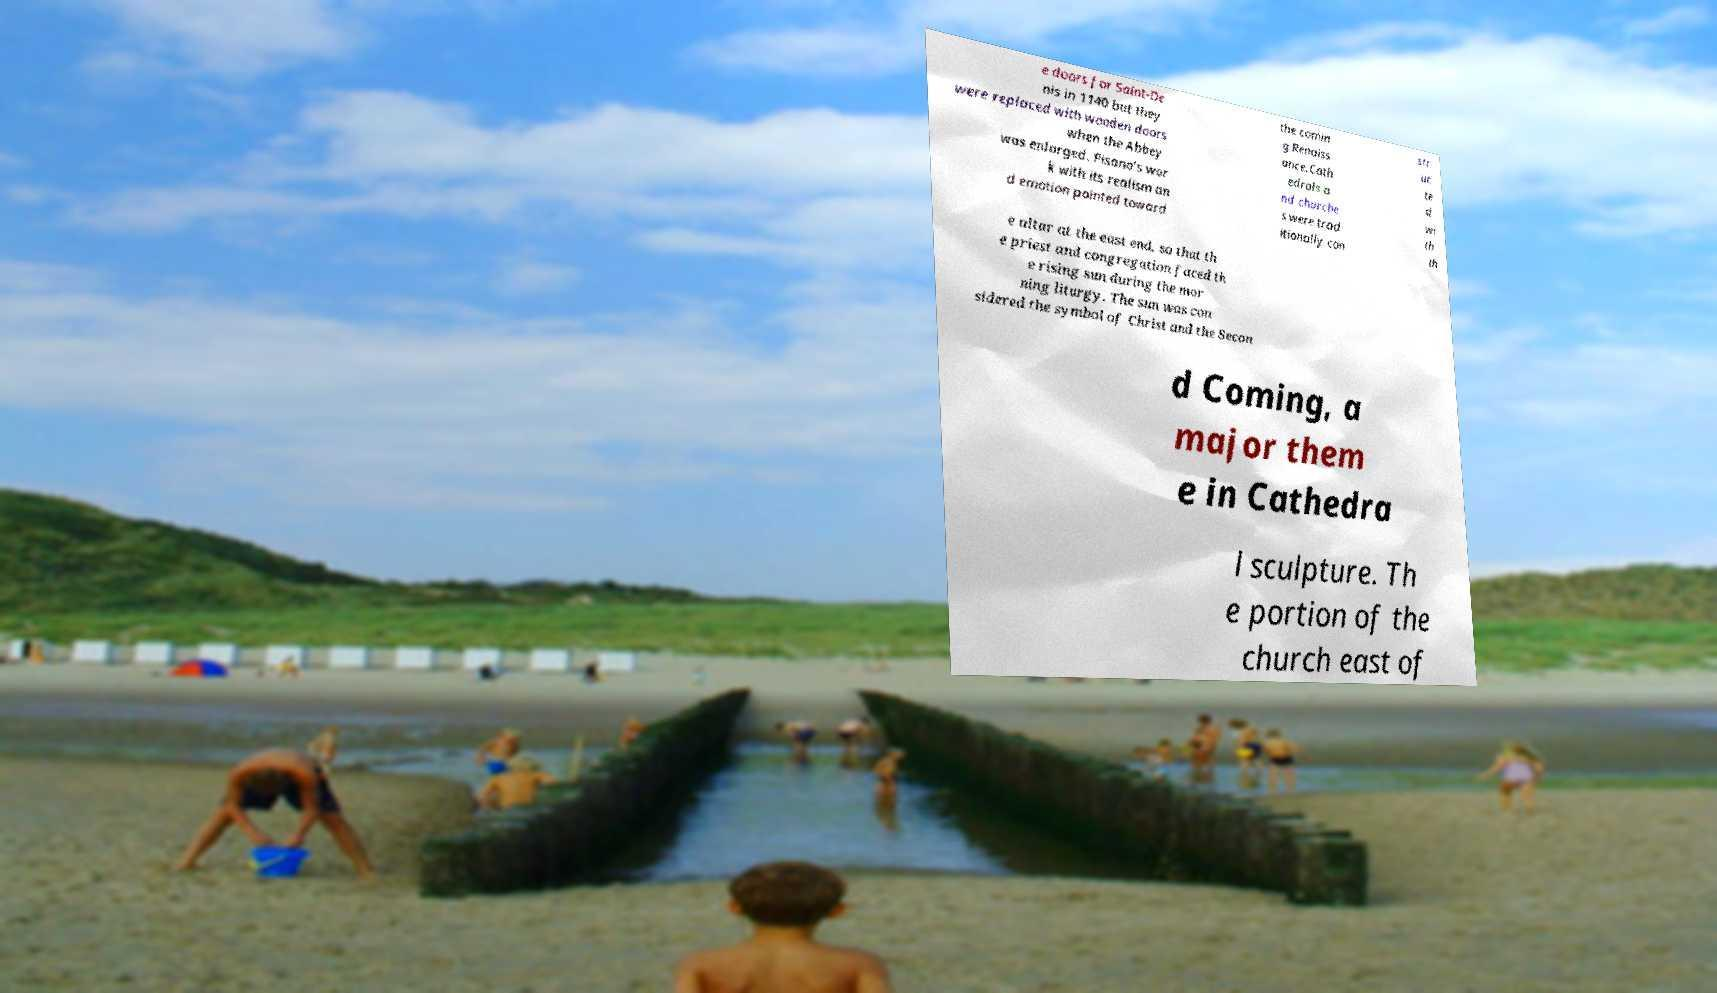There's text embedded in this image that I need extracted. Can you transcribe it verbatim? e doors for Saint-De nis in 1140 but they were replaced with wooden doors when the Abbey was enlarged. Pisano's wor k with its realism an d emotion pointed toward the comin g Renaiss ance.Cath edrals a nd churche s were trad itionally con str uc te d wi th th e altar at the east end, so that th e priest and congregation faced th e rising sun during the mor ning liturgy. The sun was con sidered the symbol of Christ and the Secon d Coming, a major them e in Cathedra l sculpture. Th e portion of the church east of 